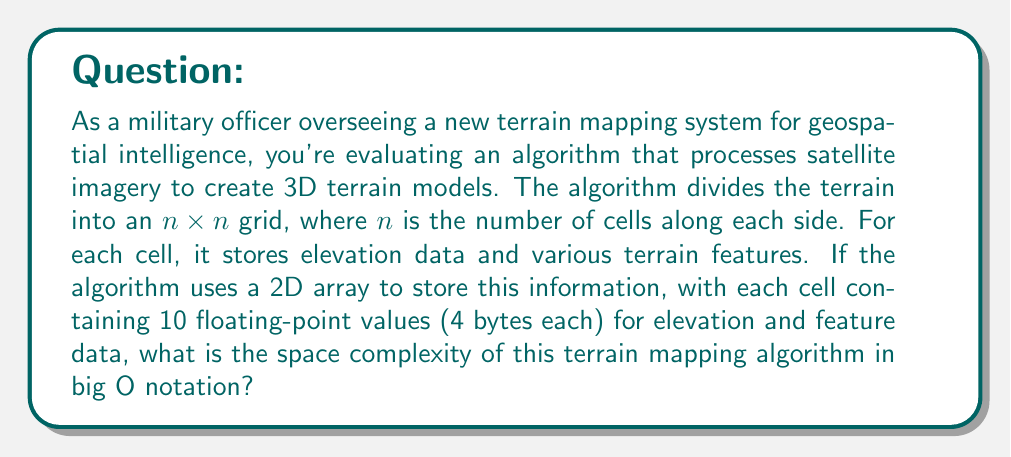Could you help me with this problem? To determine the space complexity of this terrain mapping algorithm, we need to analyze how the memory usage grows with respect to the input size. Let's break it down step by step:

1. The terrain is divided into an $n \times n$ grid, where $n$ is the number of cells along each side.

2. The total number of cells in the grid is $n^2$.

3. Each cell contains 10 floating-point values:
   - Number of values per cell = 10
   - Size of each floating-point value = 4 bytes

4. The total memory used for each cell:
   $\text{Memory per cell} = 10 \times 4 \text{ bytes} = 40 \text{ bytes}$

5. The total memory used for the entire grid:
   $\text{Total memory} = n^2 \times 40 \text{ bytes}$

6. In big O notation, we're interested in the growth rate with respect to $n$, not the constant factors. Therefore, we can simplify this to:
   $O(n^2)$

The space complexity grows quadratically with the input size $n$, which is the number of cells along each side of the grid. This is because we're using a 2D array to store the data, and the number of cells grows as the square of the grid's side length.

It's worth noting that this space complexity is typical for algorithms that process 2D spatial data, such as terrain maps or satellite imagery. In geospatial intelligence applications, this level of memory usage is often necessary to maintain high-resolution data for accurate terrain analysis and mission planning.
Answer: The space complexity of the terrain mapping algorithm is $O(n^2)$. 